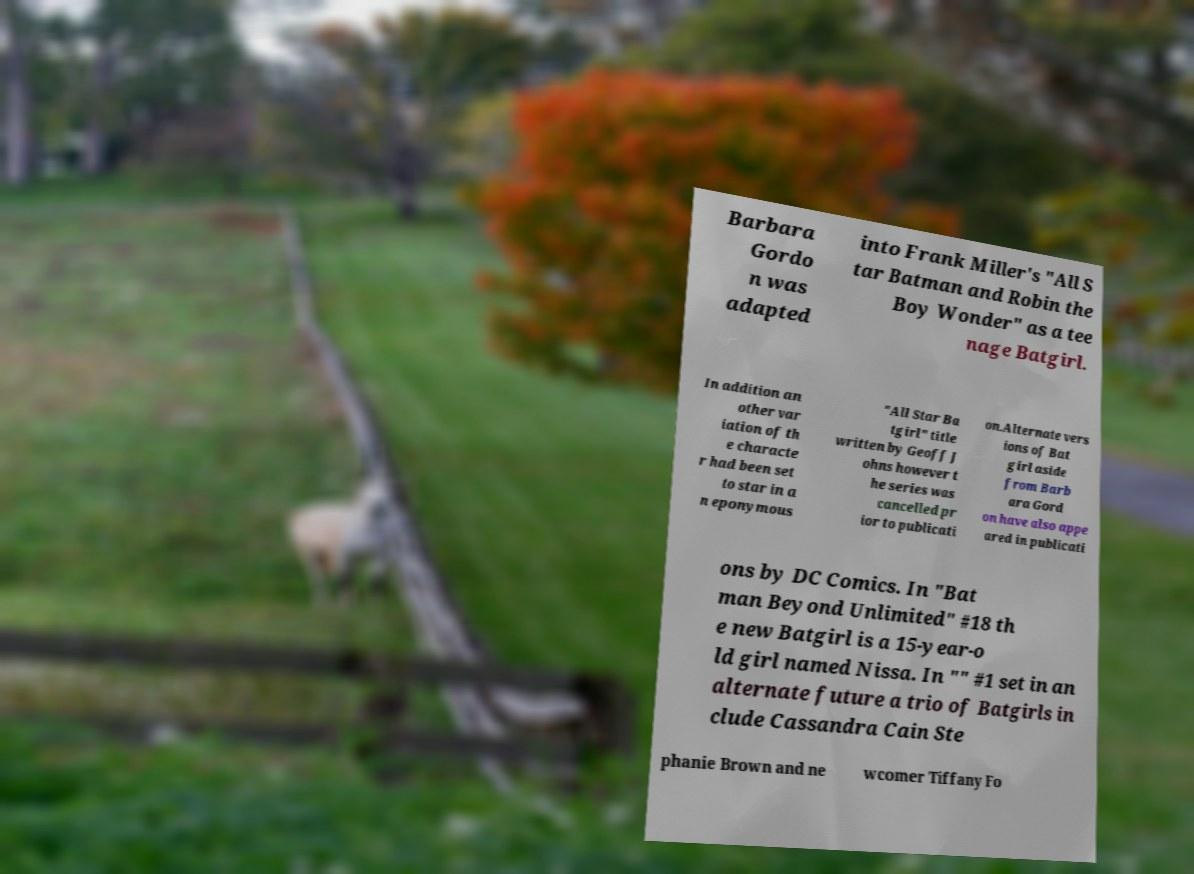There's text embedded in this image that I need extracted. Can you transcribe it verbatim? Barbara Gordo n was adapted into Frank Miller's "All S tar Batman and Robin the Boy Wonder" as a tee nage Batgirl. In addition an other var iation of th e characte r had been set to star in a n eponymous "All Star Ba tgirl" title written by Geoff J ohns however t he series was cancelled pr ior to publicati on.Alternate vers ions of Bat girl aside from Barb ara Gord on have also appe ared in publicati ons by DC Comics. In "Bat man Beyond Unlimited" #18 th e new Batgirl is a 15-year-o ld girl named Nissa. In "" #1 set in an alternate future a trio of Batgirls in clude Cassandra Cain Ste phanie Brown and ne wcomer Tiffany Fo 